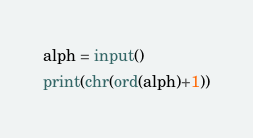<code> <loc_0><loc_0><loc_500><loc_500><_Python_>alph = input()
print(chr(ord(alph)+1))</code> 